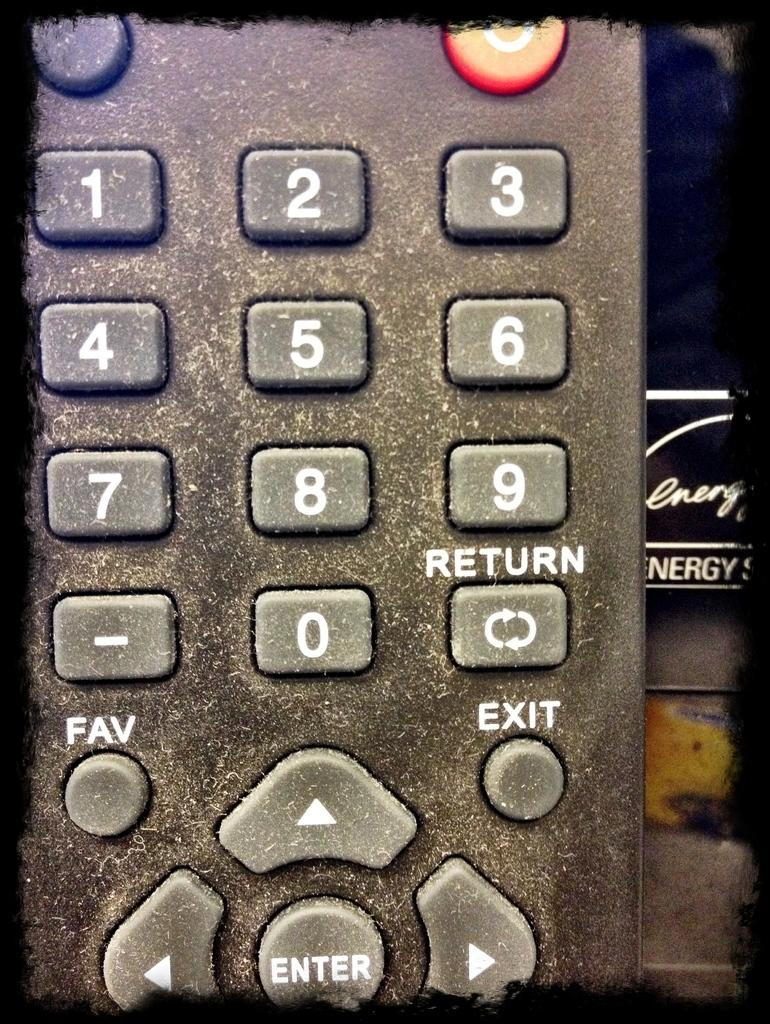<image>
Give a short and clear explanation of the subsequent image. a remote control showing the enter button a the bottom 